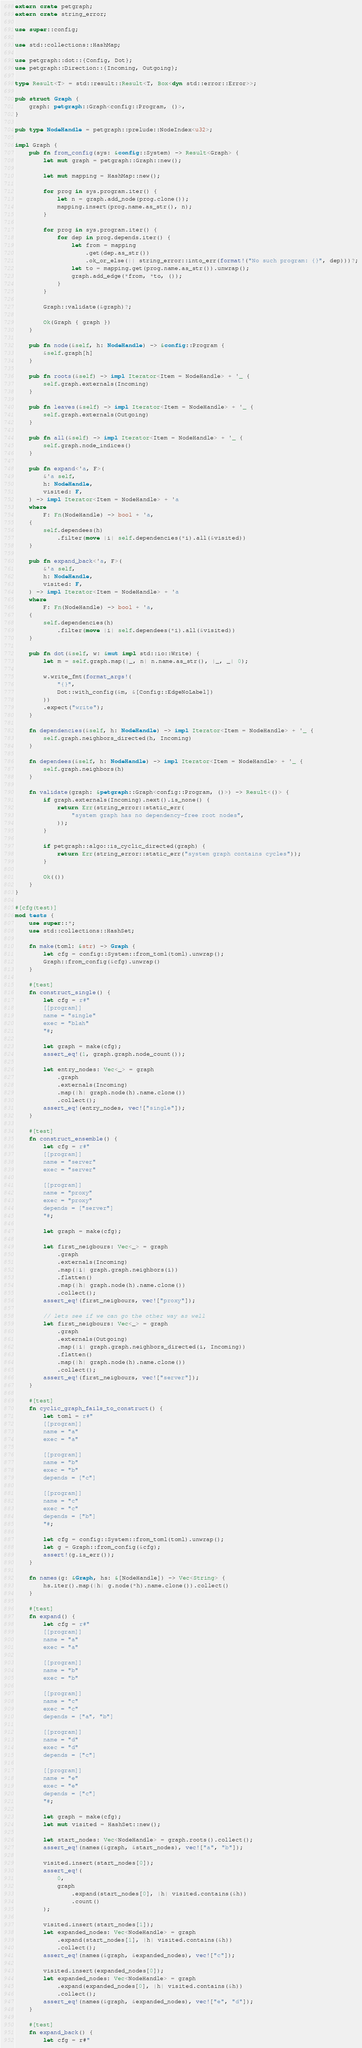<code> <loc_0><loc_0><loc_500><loc_500><_Rust_>extern crate petgraph;
extern crate string_error;

use super::config;

use std::collections::HashMap;

use petgraph::dot::{Config, Dot};
use petgraph::Direction::{Incoming, Outgoing};

type Result<T> = std::result::Result<T, Box<dyn std::error::Error>>;

pub struct Graph {
    graph: petgraph::Graph<config::Program, ()>,
}

pub type NodeHandle = petgraph::prelude::NodeIndex<u32>;

impl Graph {
    pub fn from_config(sys: &config::System) -> Result<Graph> {
        let mut graph = petgraph::Graph::new();

        let mut mapping = HashMap::new();

        for prog in sys.program.iter() {
            let n = graph.add_node(prog.clone());
            mapping.insert(prog.name.as_str(), n);
        }

        for prog in sys.program.iter() {
            for dep in prog.depends.iter() {
                let from = mapping
                    .get(dep.as_str())
                    .ok_or_else(|| string_error::into_err(format!("No such program: {}", dep)))?;
                let to = mapping.get(prog.name.as_str()).unwrap();
                graph.add_edge(*from, *to, ());
            }
        }

        Graph::validate(&graph)?;

        Ok(Graph { graph })
    }

    pub fn node(&self, h: NodeHandle) -> &config::Program {
        &self.graph[h]
    }

    pub fn roots(&self) -> impl Iterator<Item = NodeHandle> + '_ {
        self.graph.externals(Incoming)
    }

    pub fn leaves(&self) -> impl Iterator<Item = NodeHandle> + '_ {
        self.graph.externals(Outgoing)
    }

    pub fn all(&self) -> impl Iterator<Item = NodeHandle> + '_ {
        self.graph.node_indices()
    }

    pub fn expand<'a, F>(
        &'a self,
        h: NodeHandle,
        visited: F,
    ) -> impl Iterator<Item = NodeHandle> + 'a
    where
        F: Fn(NodeHandle) -> bool + 'a,
    {
        self.dependees(h)
            .filter(move |i| self.dependencies(*i).all(&visited))
    }

    pub fn expand_back<'a, F>(
        &'a self,
        h: NodeHandle,
        visited: F,
    ) -> impl Iterator<Item = NodeHandle> + 'a
    where
        F: Fn(NodeHandle) -> bool + 'a,
    {
        self.dependencies(h)
            .filter(move |i| self.dependees(*i).all(&visited))
    }

    pub fn dot(&self, w: &mut impl std::io::Write) {
        let m = self.graph.map(|_, n| n.name.as_str(), |_, _| 0);

        w.write_fmt(format_args!(
            "{}",
            Dot::with_config(&m, &[Config::EdgeNoLabel])
        ))
        .expect("write");
    }

    fn dependencies(&self, h: NodeHandle) -> impl Iterator<Item = NodeHandle> + '_ {
        self.graph.neighbors_directed(h, Incoming)
    }

    fn dependees(&self, h: NodeHandle) -> impl Iterator<Item = NodeHandle> + '_ {
        self.graph.neighbors(h)
    }

    fn validate(graph: &petgraph::Graph<config::Program, ()>) -> Result<()> {
        if graph.externals(Incoming).next().is_none() {
            return Err(string_error::static_err(
                "system graph has no dependency-free root nodes",
            ));
        }

        if petgraph::algo::is_cyclic_directed(graph) {
            return Err(string_error::static_err("system graph contains cycles"));
        }

        Ok(())
    }
}

#[cfg(test)]
mod tests {
    use super::*;
    use std::collections::HashSet;

    fn make(toml: &str) -> Graph {
        let cfg = config::System::from_toml(toml).unwrap();
        Graph::from_config(&cfg).unwrap()
    }

    #[test]
    fn construct_single() {
        let cfg = r#"
        [[program]]
        name = "single"
        exec = "blah"
        "#;

        let graph = make(cfg);
        assert_eq!(1, graph.graph.node_count());

        let entry_nodes: Vec<_> = graph
            .graph
            .externals(Incoming)
            .map(|h| graph.node(h).name.clone())
            .collect();
        assert_eq!(entry_nodes, vec!["single"]);
    }

    #[test]
    fn construct_ensemble() {
        let cfg = r#"
        [[program]]
        name = "server"
        exec = "server"

        [[program]]
        name = "proxy"
        exec = "proxy"
        depends = ["server"]
        "#;

        let graph = make(cfg);

        let first_neigbours: Vec<_> = graph
            .graph
            .externals(Incoming)
            .map(|i| graph.graph.neighbors(i))
            .flatten()
            .map(|h| graph.node(h).name.clone())
            .collect();
        assert_eq!(first_neigbours, vec!["proxy"]);

        // lets see if we can go the other way as well
        let first_neigbours: Vec<_> = graph
            .graph
            .externals(Outgoing)
            .map(|i| graph.graph.neighbors_directed(i, Incoming))
            .flatten()
            .map(|h| graph.node(h).name.clone())
            .collect();
        assert_eq!(first_neigbours, vec!["server"]);
    }

    #[test]
    fn cyclic_graph_fails_to_construct() {
        let toml = r#"
        [[program]]
        name = "a"
        exec = "a"

        [[program]]
        name = "b"
        exec = "b"
        depends = ["c"]

        [[program]]
        name = "c"
        exec = "c"
        depends = ["b"]
        "#;

        let cfg = config::System::from_toml(toml).unwrap();
        let g = Graph::from_config(&cfg);
        assert!(g.is_err());
    }

    fn names(g: &Graph, hs: &[NodeHandle]) -> Vec<String> {
        hs.iter().map(|h| g.node(*h).name.clone()).collect()
    }

    #[test]
    fn expand() {
        let cfg = r#"
        [[program]]
        name = "a"
        exec = "a"

        [[program]]
        name = "b"
        exec = "b"

        [[program]]
        name = "c"
        exec = "c"
        depends = ["a", "b"]

        [[program]]
        name = "d"
        exec = "d"
        depends = ["c"]

        [[program]]
        name = "e"
        exec = "e"
        depends = ["c"]
        "#;

        let graph = make(cfg);
        let mut visited = HashSet::new();

        let start_nodes: Vec<NodeHandle> = graph.roots().collect();
        assert_eq!(names(&graph, &start_nodes), vec!["a", "b"]);

        visited.insert(start_nodes[0]);
        assert_eq!(
            0,
            graph
                .expand(start_nodes[0], |h| visited.contains(&h))
                .count()
        );

        visited.insert(start_nodes[1]);
        let expanded_nodes: Vec<NodeHandle> = graph
            .expand(start_nodes[1], |h| visited.contains(&h))
            .collect();
        assert_eq!(names(&graph, &expanded_nodes), vec!["c"]);

        visited.insert(expanded_nodes[0]);
        let expanded_nodes: Vec<NodeHandle> = graph
            .expand(expanded_nodes[0], |h| visited.contains(&h))
            .collect();
        assert_eq!(names(&graph, &expanded_nodes), vec!["e", "d"]);
    }

    #[test]
    fn expand_back() {
        let cfg = r#"</code> 